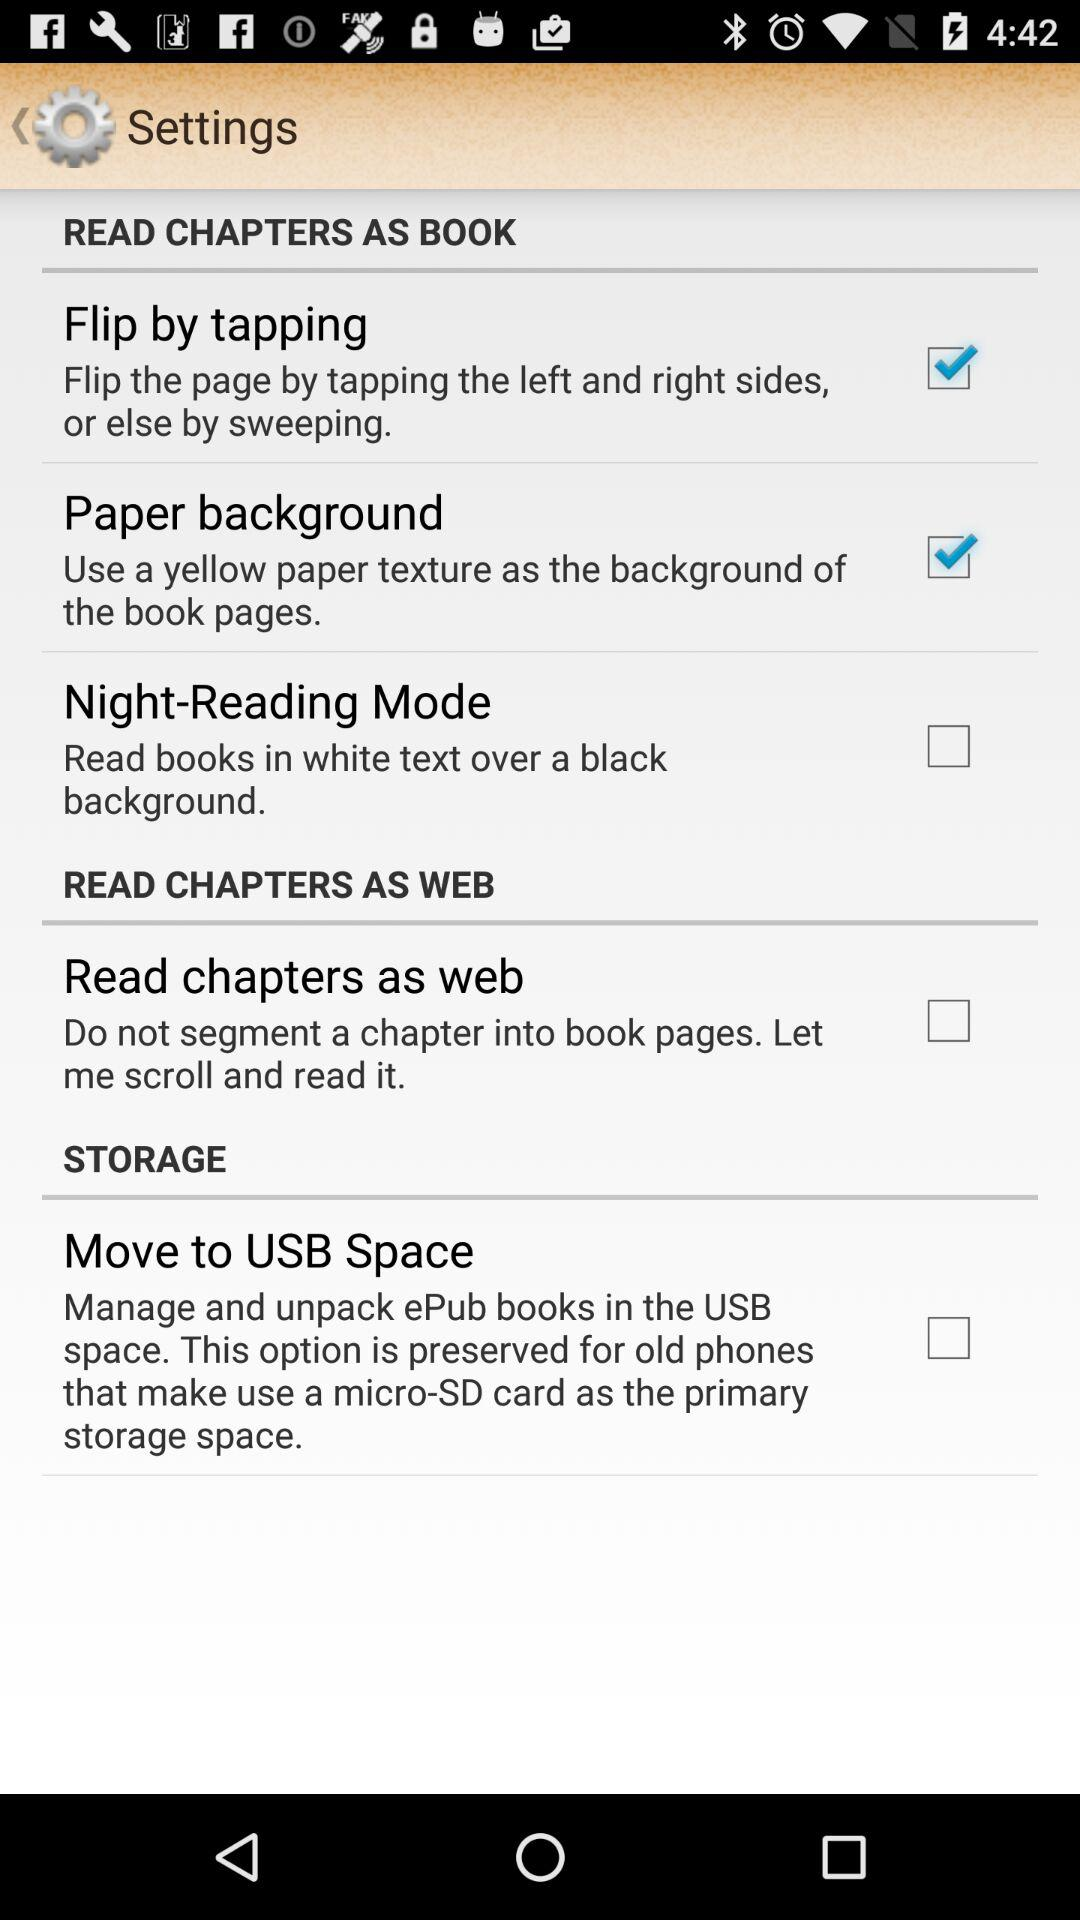How many options are there to customize the reading experience?
Answer the question using a single word or phrase. 4 